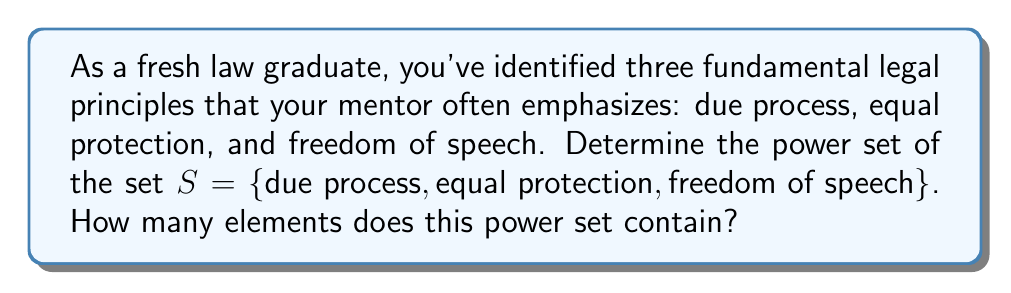Can you solve this math problem? To solve this problem, let's break it down into steps:

1) First, recall that the power set of a set $S$ is the set of all subsets of $S$, including the empty set and $S$ itself.

2) For a set with $n$ elements, the number of elements in its power set is $2^n$.

3) In this case, our set $S$ has 3 elements:
   $S = \{\text{due process}, \text{equal protection}, \text{freedom of speech}\}$

4) Therefore, the number of elements in the power set will be $2^3 = 8$.

5) Let's list all these subsets:

   - The empty set: $\{\}$
   - Single element subsets: $\{\text{due process}\}$, $\{\text{equal protection}\}$, $\{\text{freedom of speech}\}$
   - Two element subsets: $\{\text{due process}, \text{equal protection}\}$, $\{\text{due process}, \text{freedom of speech}\}$, $\{\text{equal protection}, \text{freedom of speech}\}$
   - The full set: $\{\text{due process}, \text{equal protection}, \text{freedom of speech}\}$

6) We can represent the power set mathematically as:

   $P(S) = \{\{\}, \{\text{due process}\}, \{\text{equal protection}\}, \{\text{freedom of speech}\}, \{\text{due process}, \text{equal protection}\}, \{\text{due process}, \text{freedom of speech}\}, \{\text{equal protection}, \text{freedom of speech}\}, \{\text{due process}, \text{equal protection}, \text{freedom of speech}\}\}$

7) As we can see, this power set indeed contains 8 elements.
Answer: The power set of $S$ contains 8 elements:

$P(S) = \{\{\}, \{\text{due process}\}, \{\text{equal protection}\}, \{\text{freedom of speech}\}, \{\text{due process}, \text{equal protection}\}, \{\text{due process}, \text{freedom of speech}\}, \{\text{equal protection}, \text{freedom of speech}\}, \{\text{due process}, \text{equal protection}, \text{freedom of speech}\}\}$ 